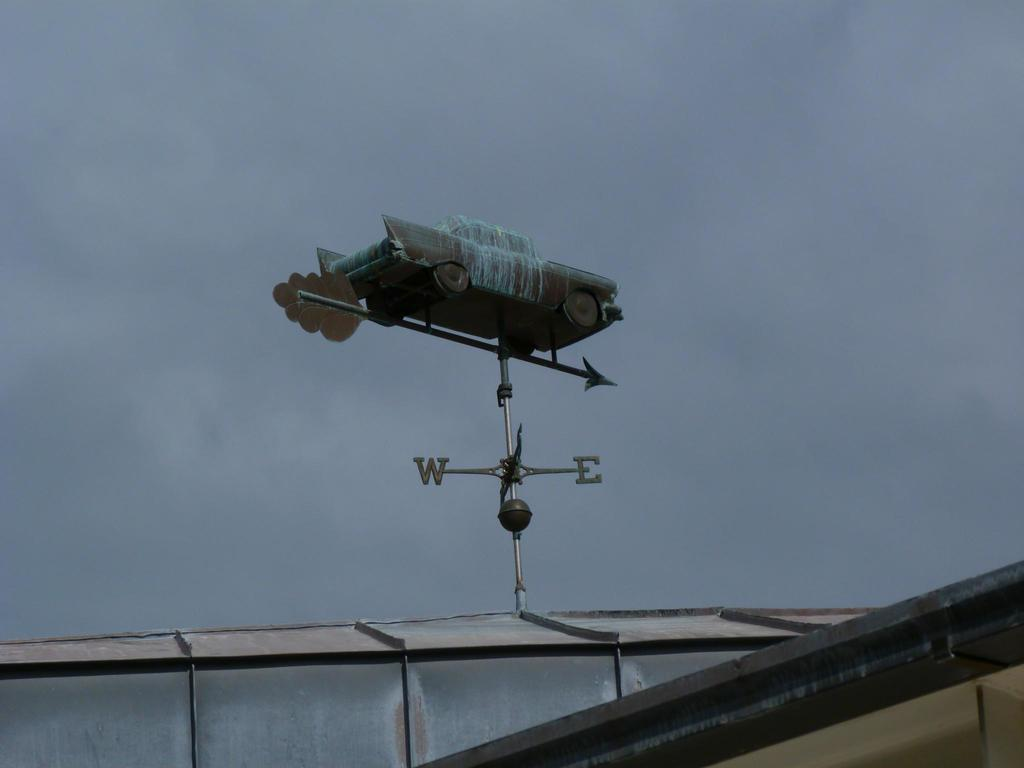<image>
Describe the image concisely. A weather vane shows the wind is blowing east. 